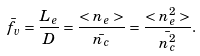<formula> <loc_0><loc_0><loc_500><loc_500>\bar { f _ { v } } = \frac { L _ { e } } { D } = \frac { < n _ { e } > } { \bar { n _ { c } } } = \frac { < n _ { e } ^ { 2 } > } { { \bar { n _ { c } ^ { 2 } } } } .</formula> 